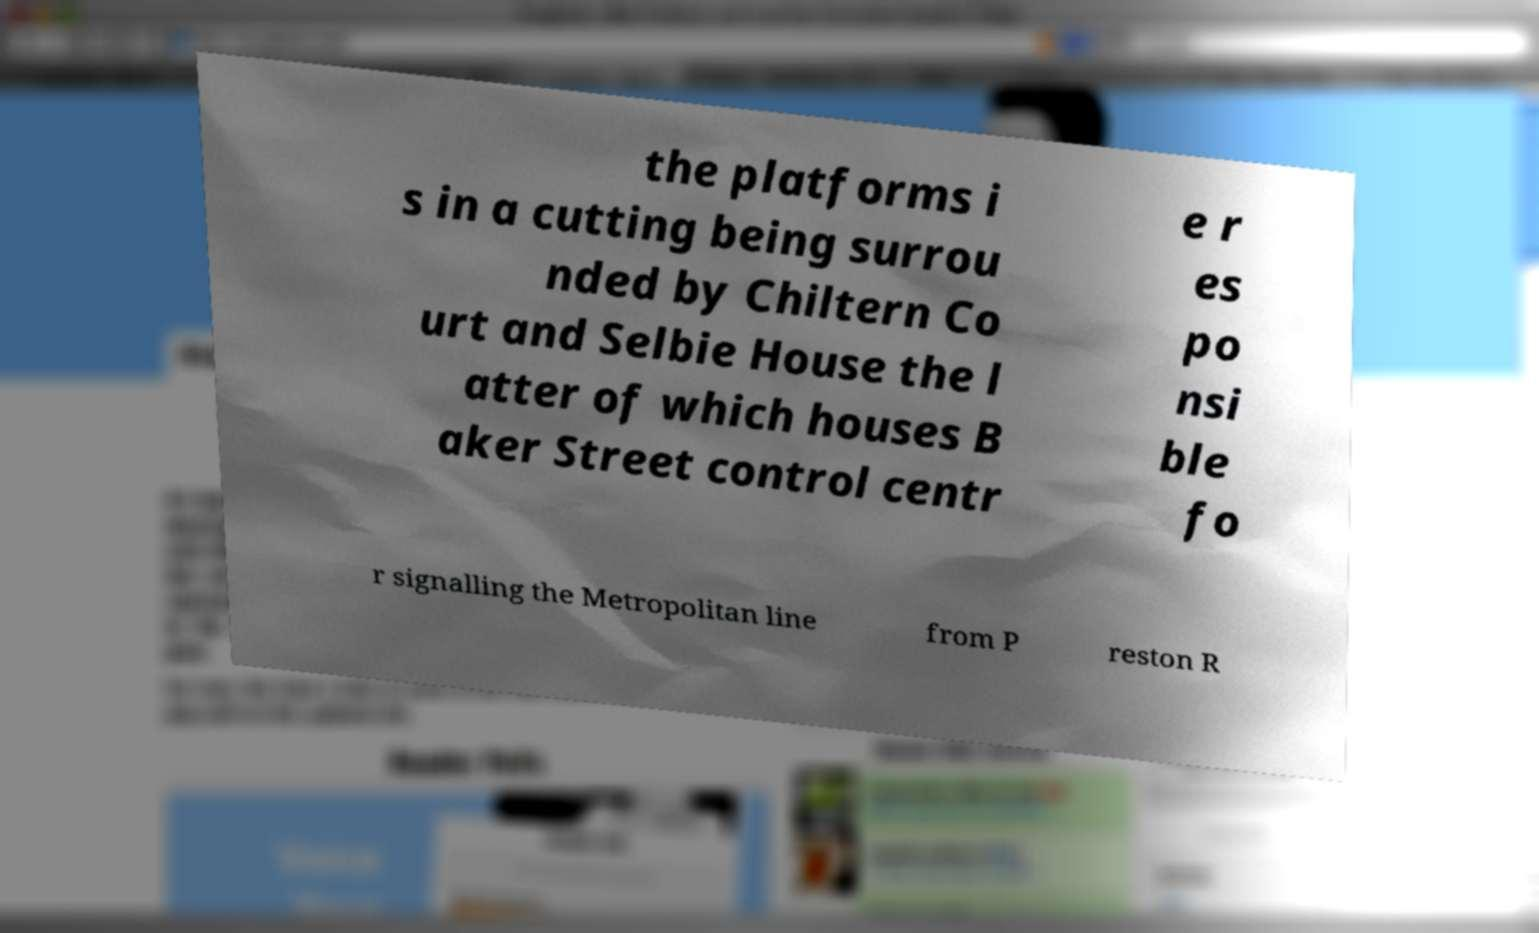What messages or text are displayed in this image? I need them in a readable, typed format. the platforms i s in a cutting being surrou nded by Chiltern Co urt and Selbie House the l atter of which houses B aker Street control centr e r es po nsi ble fo r signalling the Metropolitan line from P reston R 